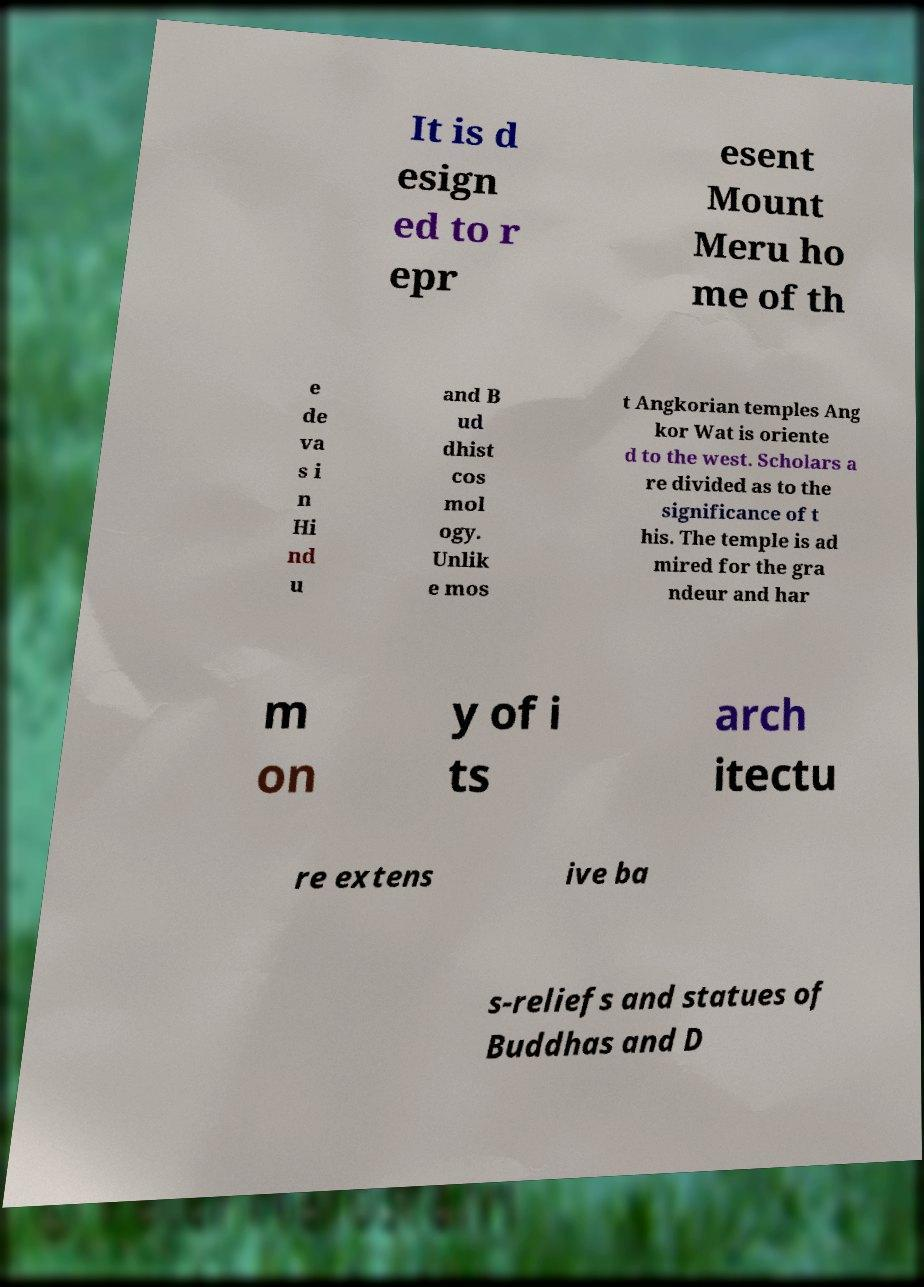Can you accurately transcribe the text from the provided image for me? It is d esign ed to r epr esent Mount Meru ho me of th e de va s i n Hi nd u and B ud dhist cos mol ogy. Unlik e mos t Angkorian temples Ang kor Wat is oriente d to the west. Scholars a re divided as to the significance of t his. The temple is ad mired for the gra ndeur and har m on y of i ts arch itectu re extens ive ba s-reliefs and statues of Buddhas and D 